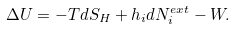<formula> <loc_0><loc_0><loc_500><loc_500>\Delta U = - T d S _ { H } + h _ { i } d N _ { i } ^ { e x t } - W .</formula> 